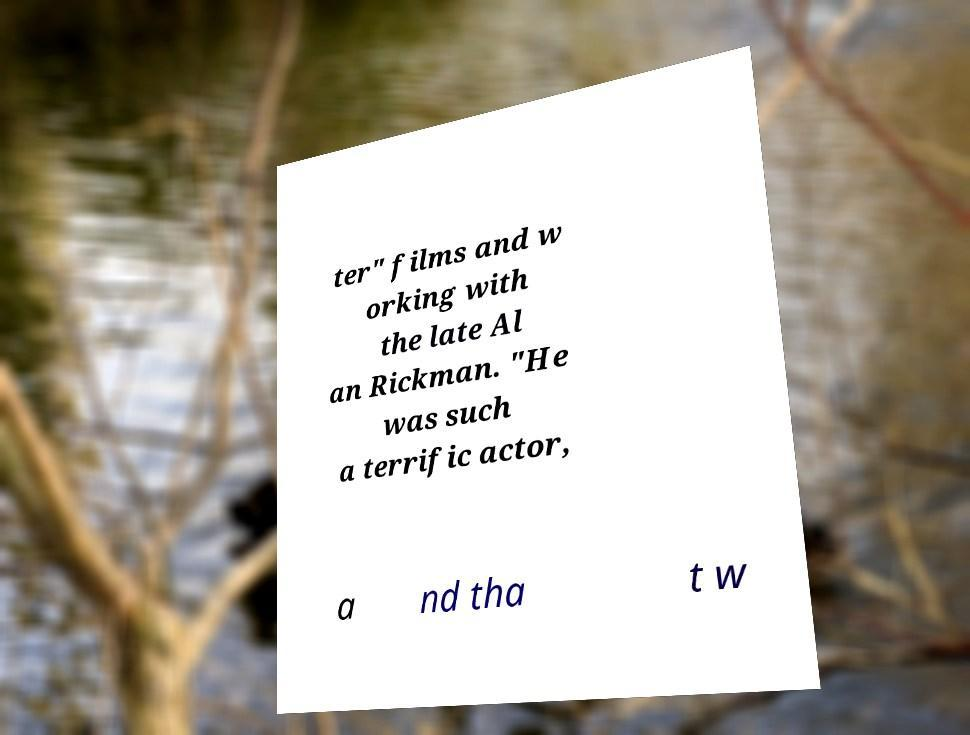There's text embedded in this image that I need extracted. Can you transcribe it verbatim? ter" films and w orking with the late Al an Rickman. "He was such a terrific actor, a nd tha t w 